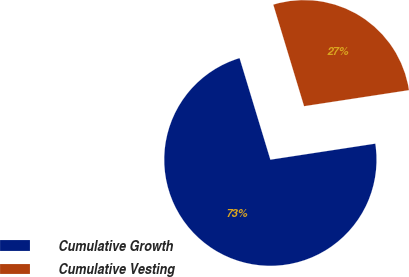Convert chart to OTSL. <chart><loc_0><loc_0><loc_500><loc_500><pie_chart><fcel>Cumulative Growth<fcel>Cumulative Vesting<nl><fcel>72.73%<fcel>27.27%<nl></chart> 